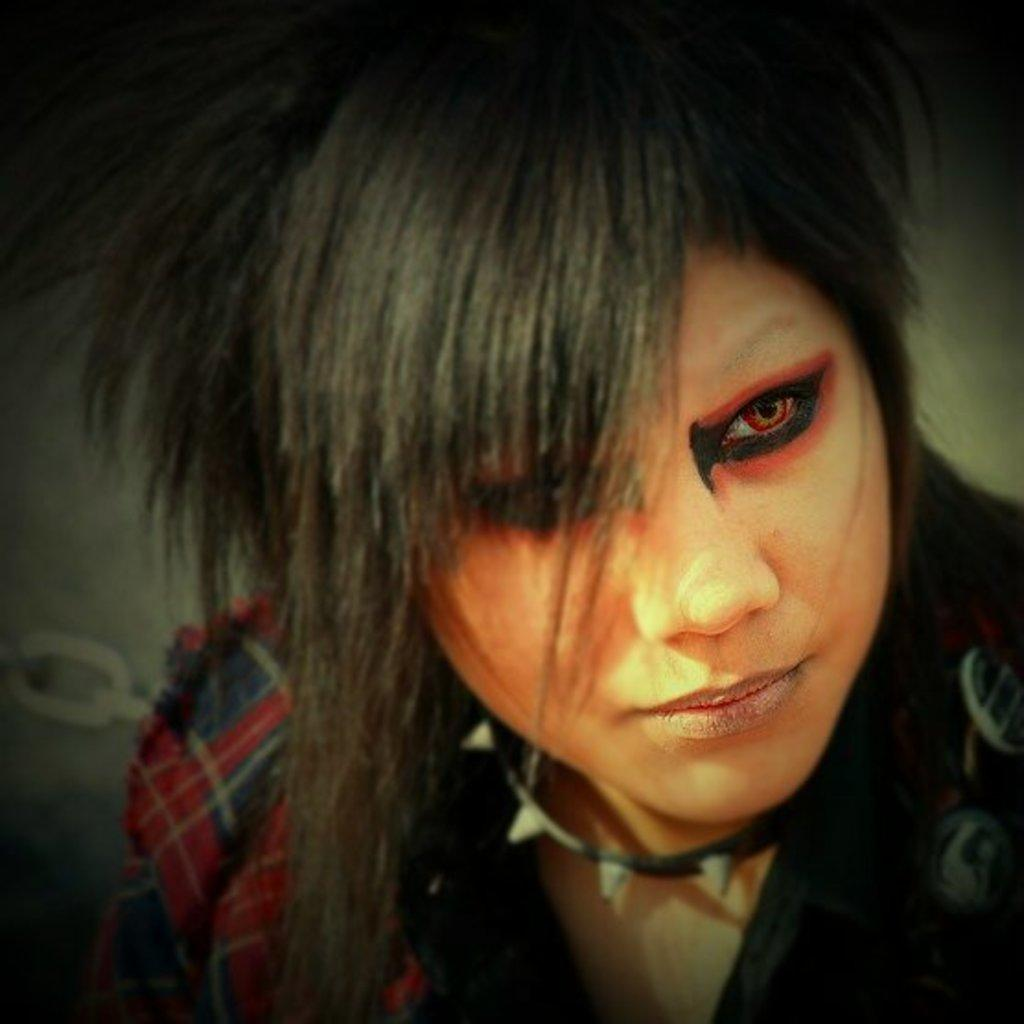What is present in the image? There is a person in the image. What is the person wearing? The person is wearing a red dress. In which direction is the person looking? The person is looking to the right side. How would you describe the background of the image? The background of the image is blurred. What activity is the person participating in at the park in the image? There is no park present in the image, and the person's activity cannot be determined from the provided facts. Can you hear the person laughing in the image? There is no sound or indication of laughter in the image. 